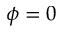Convert formula to latex. <formula><loc_0><loc_0><loc_500><loc_500>\phi = 0</formula> 